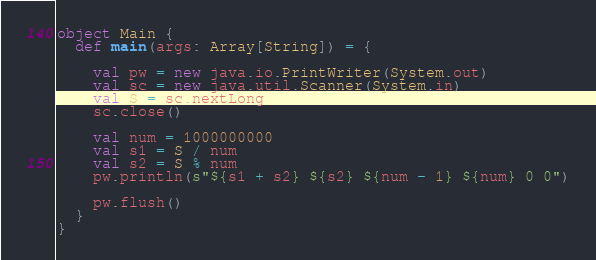<code> <loc_0><loc_0><loc_500><loc_500><_Scala_>object Main {
  def main(args: Array[String]) = {

    val pw = new java.io.PrintWriter(System.out)
    val sc = new java.util.Scanner(System.in)
    val S = sc.nextLong
    sc.close()

    val num = 1000000000
    val s1 = S / num
    val s2 = S % num
    pw.println(s"${s1 + s2} ${s2} ${num - 1} ${num} 0 0")

    pw.flush()
  }
}</code> 